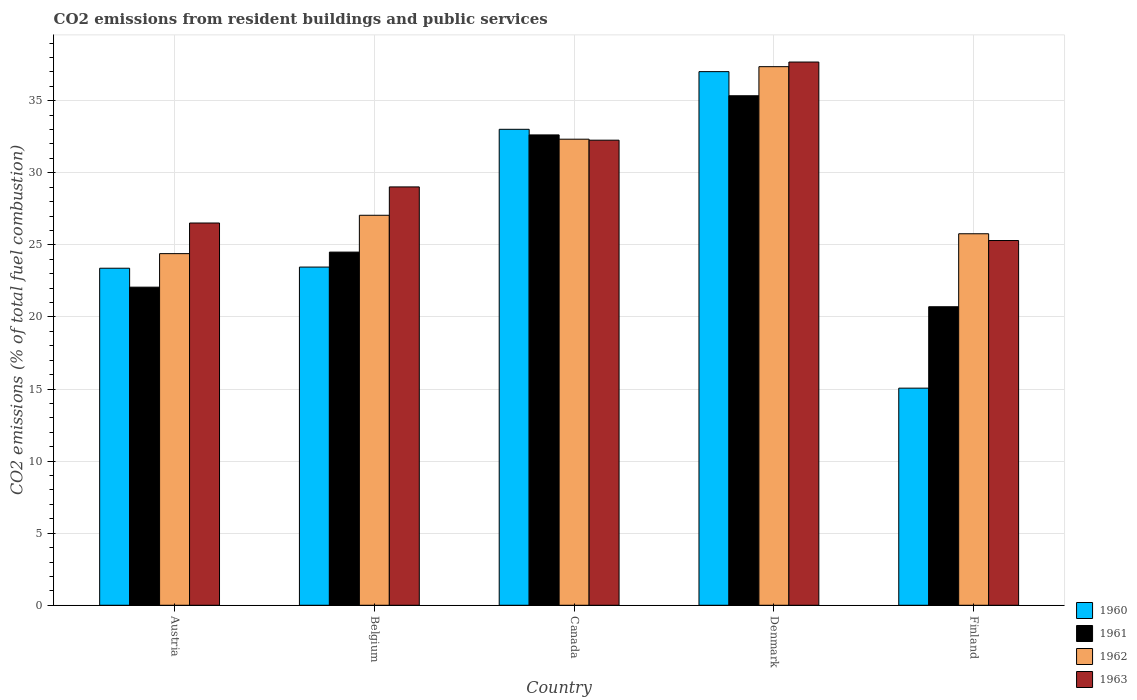How many different coloured bars are there?
Your response must be concise. 4. How many groups of bars are there?
Your answer should be very brief. 5. Are the number of bars on each tick of the X-axis equal?
Provide a short and direct response. Yes. In how many cases, is the number of bars for a given country not equal to the number of legend labels?
Your response must be concise. 0. What is the total CO2 emitted in 1960 in Austria?
Make the answer very short. 23.38. Across all countries, what is the maximum total CO2 emitted in 1960?
Keep it short and to the point. 37.02. Across all countries, what is the minimum total CO2 emitted in 1963?
Your response must be concise. 25.3. In which country was the total CO2 emitted in 1962 minimum?
Give a very brief answer. Austria. What is the total total CO2 emitted in 1962 in the graph?
Give a very brief answer. 146.9. What is the difference between the total CO2 emitted in 1963 in Austria and that in Denmark?
Provide a succinct answer. -11.17. What is the difference between the total CO2 emitted in 1963 in Belgium and the total CO2 emitted in 1962 in Canada?
Your response must be concise. -3.31. What is the average total CO2 emitted in 1962 per country?
Offer a terse response. 29.38. What is the difference between the total CO2 emitted of/in 1963 and total CO2 emitted of/in 1960 in Canada?
Make the answer very short. -0.75. What is the ratio of the total CO2 emitted in 1960 in Austria to that in Belgium?
Your answer should be very brief. 1. Is the total CO2 emitted in 1963 in Austria less than that in Denmark?
Offer a very short reply. Yes. What is the difference between the highest and the second highest total CO2 emitted in 1960?
Provide a short and direct response. -4. What is the difference between the highest and the lowest total CO2 emitted in 1961?
Ensure brevity in your answer.  14.64. In how many countries, is the total CO2 emitted in 1961 greater than the average total CO2 emitted in 1961 taken over all countries?
Make the answer very short. 2. Is the sum of the total CO2 emitted in 1961 in Belgium and Denmark greater than the maximum total CO2 emitted in 1960 across all countries?
Your answer should be compact. Yes. Is it the case that in every country, the sum of the total CO2 emitted in 1960 and total CO2 emitted in 1962 is greater than the sum of total CO2 emitted in 1963 and total CO2 emitted in 1961?
Keep it short and to the point. No. What does the 2nd bar from the right in Belgium represents?
Provide a succinct answer. 1962. How many bars are there?
Keep it short and to the point. 20. Are the values on the major ticks of Y-axis written in scientific E-notation?
Make the answer very short. No. Does the graph contain any zero values?
Provide a short and direct response. No. Does the graph contain grids?
Your answer should be compact. Yes. How many legend labels are there?
Keep it short and to the point. 4. What is the title of the graph?
Make the answer very short. CO2 emissions from resident buildings and public services. What is the label or title of the X-axis?
Your answer should be compact. Country. What is the label or title of the Y-axis?
Provide a short and direct response. CO2 emissions (% of total fuel combustion). What is the CO2 emissions (% of total fuel combustion) in 1960 in Austria?
Make the answer very short. 23.38. What is the CO2 emissions (% of total fuel combustion) in 1961 in Austria?
Give a very brief answer. 22.06. What is the CO2 emissions (% of total fuel combustion) of 1962 in Austria?
Ensure brevity in your answer.  24.39. What is the CO2 emissions (% of total fuel combustion) of 1963 in Austria?
Give a very brief answer. 26.52. What is the CO2 emissions (% of total fuel combustion) of 1960 in Belgium?
Ensure brevity in your answer.  23.46. What is the CO2 emissions (% of total fuel combustion) in 1961 in Belgium?
Keep it short and to the point. 24.5. What is the CO2 emissions (% of total fuel combustion) of 1962 in Belgium?
Your answer should be very brief. 27.05. What is the CO2 emissions (% of total fuel combustion) of 1963 in Belgium?
Provide a short and direct response. 29.02. What is the CO2 emissions (% of total fuel combustion) of 1960 in Canada?
Offer a terse response. 33.01. What is the CO2 emissions (% of total fuel combustion) of 1961 in Canada?
Offer a terse response. 32.63. What is the CO2 emissions (% of total fuel combustion) of 1962 in Canada?
Provide a succinct answer. 32.33. What is the CO2 emissions (% of total fuel combustion) of 1963 in Canada?
Make the answer very short. 32.26. What is the CO2 emissions (% of total fuel combustion) in 1960 in Denmark?
Provide a succinct answer. 37.02. What is the CO2 emissions (% of total fuel combustion) of 1961 in Denmark?
Provide a short and direct response. 35.34. What is the CO2 emissions (% of total fuel combustion) in 1962 in Denmark?
Provide a short and direct response. 37.36. What is the CO2 emissions (% of total fuel combustion) of 1963 in Denmark?
Provide a short and direct response. 37.68. What is the CO2 emissions (% of total fuel combustion) in 1960 in Finland?
Provide a short and direct response. 15.06. What is the CO2 emissions (% of total fuel combustion) in 1961 in Finland?
Provide a short and direct response. 20.71. What is the CO2 emissions (% of total fuel combustion) of 1962 in Finland?
Provide a short and direct response. 25.77. What is the CO2 emissions (% of total fuel combustion) of 1963 in Finland?
Your response must be concise. 25.3. Across all countries, what is the maximum CO2 emissions (% of total fuel combustion) in 1960?
Your answer should be very brief. 37.02. Across all countries, what is the maximum CO2 emissions (% of total fuel combustion) in 1961?
Your response must be concise. 35.34. Across all countries, what is the maximum CO2 emissions (% of total fuel combustion) of 1962?
Provide a succinct answer. 37.36. Across all countries, what is the maximum CO2 emissions (% of total fuel combustion) of 1963?
Your response must be concise. 37.68. Across all countries, what is the minimum CO2 emissions (% of total fuel combustion) of 1960?
Offer a terse response. 15.06. Across all countries, what is the minimum CO2 emissions (% of total fuel combustion) of 1961?
Make the answer very short. 20.71. Across all countries, what is the minimum CO2 emissions (% of total fuel combustion) of 1962?
Your response must be concise. 24.39. Across all countries, what is the minimum CO2 emissions (% of total fuel combustion) in 1963?
Your answer should be very brief. 25.3. What is the total CO2 emissions (% of total fuel combustion) in 1960 in the graph?
Offer a very short reply. 131.93. What is the total CO2 emissions (% of total fuel combustion) of 1961 in the graph?
Provide a short and direct response. 135.24. What is the total CO2 emissions (% of total fuel combustion) of 1962 in the graph?
Ensure brevity in your answer.  146.9. What is the total CO2 emissions (% of total fuel combustion) of 1963 in the graph?
Provide a short and direct response. 150.78. What is the difference between the CO2 emissions (% of total fuel combustion) in 1960 in Austria and that in Belgium?
Ensure brevity in your answer.  -0.08. What is the difference between the CO2 emissions (% of total fuel combustion) in 1961 in Austria and that in Belgium?
Provide a short and direct response. -2.43. What is the difference between the CO2 emissions (% of total fuel combustion) in 1962 in Austria and that in Belgium?
Make the answer very short. -2.66. What is the difference between the CO2 emissions (% of total fuel combustion) in 1963 in Austria and that in Belgium?
Keep it short and to the point. -2.5. What is the difference between the CO2 emissions (% of total fuel combustion) of 1960 in Austria and that in Canada?
Make the answer very short. -9.64. What is the difference between the CO2 emissions (% of total fuel combustion) of 1961 in Austria and that in Canada?
Offer a terse response. -10.56. What is the difference between the CO2 emissions (% of total fuel combustion) of 1962 in Austria and that in Canada?
Your answer should be very brief. -7.94. What is the difference between the CO2 emissions (% of total fuel combustion) of 1963 in Austria and that in Canada?
Provide a succinct answer. -5.74. What is the difference between the CO2 emissions (% of total fuel combustion) in 1960 in Austria and that in Denmark?
Give a very brief answer. -13.64. What is the difference between the CO2 emissions (% of total fuel combustion) of 1961 in Austria and that in Denmark?
Keep it short and to the point. -13.28. What is the difference between the CO2 emissions (% of total fuel combustion) of 1962 in Austria and that in Denmark?
Your answer should be compact. -12.97. What is the difference between the CO2 emissions (% of total fuel combustion) of 1963 in Austria and that in Denmark?
Give a very brief answer. -11.17. What is the difference between the CO2 emissions (% of total fuel combustion) in 1960 in Austria and that in Finland?
Provide a succinct answer. 8.32. What is the difference between the CO2 emissions (% of total fuel combustion) in 1961 in Austria and that in Finland?
Your answer should be very brief. 1.36. What is the difference between the CO2 emissions (% of total fuel combustion) of 1962 in Austria and that in Finland?
Offer a very short reply. -1.38. What is the difference between the CO2 emissions (% of total fuel combustion) of 1963 in Austria and that in Finland?
Provide a short and direct response. 1.22. What is the difference between the CO2 emissions (% of total fuel combustion) in 1960 in Belgium and that in Canada?
Give a very brief answer. -9.56. What is the difference between the CO2 emissions (% of total fuel combustion) in 1961 in Belgium and that in Canada?
Offer a terse response. -8.13. What is the difference between the CO2 emissions (% of total fuel combustion) of 1962 in Belgium and that in Canada?
Your answer should be compact. -5.28. What is the difference between the CO2 emissions (% of total fuel combustion) in 1963 in Belgium and that in Canada?
Make the answer very short. -3.24. What is the difference between the CO2 emissions (% of total fuel combustion) in 1960 in Belgium and that in Denmark?
Provide a succinct answer. -13.56. What is the difference between the CO2 emissions (% of total fuel combustion) in 1961 in Belgium and that in Denmark?
Ensure brevity in your answer.  -10.85. What is the difference between the CO2 emissions (% of total fuel combustion) in 1962 in Belgium and that in Denmark?
Make the answer very short. -10.31. What is the difference between the CO2 emissions (% of total fuel combustion) in 1963 in Belgium and that in Denmark?
Ensure brevity in your answer.  -8.66. What is the difference between the CO2 emissions (% of total fuel combustion) of 1960 in Belgium and that in Finland?
Your answer should be very brief. 8.4. What is the difference between the CO2 emissions (% of total fuel combustion) of 1961 in Belgium and that in Finland?
Ensure brevity in your answer.  3.79. What is the difference between the CO2 emissions (% of total fuel combustion) in 1962 in Belgium and that in Finland?
Your answer should be very brief. 1.28. What is the difference between the CO2 emissions (% of total fuel combustion) in 1963 in Belgium and that in Finland?
Ensure brevity in your answer.  3.72. What is the difference between the CO2 emissions (% of total fuel combustion) of 1960 in Canada and that in Denmark?
Make the answer very short. -4. What is the difference between the CO2 emissions (% of total fuel combustion) of 1961 in Canada and that in Denmark?
Ensure brevity in your answer.  -2.72. What is the difference between the CO2 emissions (% of total fuel combustion) of 1962 in Canada and that in Denmark?
Your answer should be very brief. -5.03. What is the difference between the CO2 emissions (% of total fuel combustion) of 1963 in Canada and that in Denmark?
Give a very brief answer. -5.42. What is the difference between the CO2 emissions (% of total fuel combustion) of 1960 in Canada and that in Finland?
Provide a succinct answer. 17.96. What is the difference between the CO2 emissions (% of total fuel combustion) of 1961 in Canada and that in Finland?
Provide a short and direct response. 11.92. What is the difference between the CO2 emissions (% of total fuel combustion) of 1962 in Canada and that in Finland?
Your response must be concise. 6.56. What is the difference between the CO2 emissions (% of total fuel combustion) in 1963 in Canada and that in Finland?
Keep it short and to the point. 6.96. What is the difference between the CO2 emissions (% of total fuel combustion) in 1960 in Denmark and that in Finland?
Make the answer very short. 21.96. What is the difference between the CO2 emissions (% of total fuel combustion) of 1961 in Denmark and that in Finland?
Make the answer very short. 14.64. What is the difference between the CO2 emissions (% of total fuel combustion) of 1962 in Denmark and that in Finland?
Give a very brief answer. 11.59. What is the difference between the CO2 emissions (% of total fuel combustion) of 1963 in Denmark and that in Finland?
Offer a terse response. 12.38. What is the difference between the CO2 emissions (% of total fuel combustion) in 1960 in Austria and the CO2 emissions (% of total fuel combustion) in 1961 in Belgium?
Offer a terse response. -1.12. What is the difference between the CO2 emissions (% of total fuel combustion) of 1960 in Austria and the CO2 emissions (% of total fuel combustion) of 1962 in Belgium?
Ensure brevity in your answer.  -3.67. What is the difference between the CO2 emissions (% of total fuel combustion) in 1960 in Austria and the CO2 emissions (% of total fuel combustion) in 1963 in Belgium?
Keep it short and to the point. -5.64. What is the difference between the CO2 emissions (% of total fuel combustion) of 1961 in Austria and the CO2 emissions (% of total fuel combustion) of 1962 in Belgium?
Keep it short and to the point. -4.99. What is the difference between the CO2 emissions (% of total fuel combustion) of 1961 in Austria and the CO2 emissions (% of total fuel combustion) of 1963 in Belgium?
Your response must be concise. -6.95. What is the difference between the CO2 emissions (% of total fuel combustion) of 1962 in Austria and the CO2 emissions (% of total fuel combustion) of 1963 in Belgium?
Provide a succinct answer. -4.63. What is the difference between the CO2 emissions (% of total fuel combustion) of 1960 in Austria and the CO2 emissions (% of total fuel combustion) of 1961 in Canada?
Ensure brevity in your answer.  -9.25. What is the difference between the CO2 emissions (% of total fuel combustion) of 1960 in Austria and the CO2 emissions (% of total fuel combustion) of 1962 in Canada?
Offer a very short reply. -8.95. What is the difference between the CO2 emissions (% of total fuel combustion) in 1960 in Austria and the CO2 emissions (% of total fuel combustion) in 1963 in Canada?
Ensure brevity in your answer.  -8.88. What is the difference between the CO2 emissions (% of total fuel combustion) of 1961 in Austria and the CO2 emissions (% of total fuel combustion) of 1962 in Canada?
Your response must be concise. -10.26. What is the difference between the CO2 emissions (% of total fuel combustion) of 1961 in Austria and the CO2 emissions (% of total fuel combustion) of 1963 in Canada?
Offer a terse response. -10.2. What is the difference between the CO2 emissions (% of total fuel combustion) in 1962 in Austria and the CO2 emissions (% of total fuel combustion) in 1963 in Canada?
Keep it short and to the point. -7.87. What is the difference between the CO2 emissions (% of total fuel combustion) of 1960 in Austria and the CO2 emissions (% of total fuel combustion) of 1961 in Denmark?
Your answer should be compact. -11.96. What is the difference between the CO2 emissions (% of total fuel combustion) of 1960 in Austria and the CO2 emissions (% of total fuel combustion) of 1962 in Denmark?
Keep it short and to the point. -13.98. What is the difference between the CO2 emissions (% of total fuel combustion) of 1960 in Austria and the CO2 emissions (% of total fuel combustion) of 1963 in Denmark?
Ensure brevity in your answer.  -14.3. What is the difference between the CO2 emissions (% of total fuel combustion) in 1961 in Austria and the CO2 emissions (% of total fuel combustion) in 1962 in Denmark?
Your response must be concise. -15.3. What is the difference between the CO2 emissions (% of total fuel combustion) in 1961 in Austria and the CO2 emissions (% of total fuel combustion) in 1963 in Denmark?
Your answer should be compact. -15.62. What is the difference between the CO2 emissions (% of total fuel combustion) in 1962 in Austria and the CO2 emissions (% of total fuel combustion) in 1963 in Denmark?
Keep it short and to the point. -13.29. What is the difference between the CO2 emissions (% of total fuel combustion) of 1960 in Austria and the CO2 emissions (% of total fuel combustion) of 1961 in Finland?
Offer a very short reply. 2.67. What is the difference between the CO2 emissions (% of total fuel combustion) of 1960 in Austria and the CO2 emissions (% of total fuel combustion) of 1962 in Finland?
Provide a succinct answer. -2.39. What is the difference between the CO2 emissions (% of total fuel combustion) of 1960 in Austria and the CO2 emissions (% of total fuel combustion) of 1963 in Finland?
Keep it short and to the point. -1.92. What is the difference between the CO2 emissions (% of total fuel combustion) in 1961 in Austria and the CO2 emissions (% of total fuel combustion) in 1962 in Finland?
Your response must be concise. -3.71. What is the difference between the CO2 emissions (% of total fuel combustion) in 1961 in Austria and the CO2 emissions (% of total fuel combustion) in 1963 in Finland?
Give a very brief answer. -3.24. What is the difference between the CO2 emissions (% of total fuel combustion) in 1962 in Austria and the CO2 emissions (% of total fuel combustion) in 1963 in Finland?
Give a very brief answer. -0.91. What is the difference between the CO2 emissions (% of total fuel combustion) in 1960 in Belgium and the CO2 emissions (% of total fuel combustion) in 1961 in Canada?
Give a very brief answer. -9.17. What is the difference between the CO2 emissions (% of total fuel combustion) of 1960 in Belgium and the CO2 emissions (% of total fuel combustion) of 1962 in Canada?
Offer a very short reply. -8.87. What is the difference between the CO2 emissions (% of total fuel combustion) of 1960 in Belgium and the CO2 emissions (% of total fuel combustion) of 1963 in Canada?
Your answer should be very brief. -8.8. What is the difference between the CO2 emissions (% of total fuel combustion) in 1961 in Belgium and the CO2 emissions (% of total fuel combustion) in 1962 in Canada?
Offer a very short reply. -7.83. What is the difference between the CO2 emissions (% of total fuel combustion) of 1961 in Belgium and the CO2 emissions (% of total fuel combustion) of 1963 in Canada?
Provide a succinct answer. -7.76. What is the difference between the CO2 emissions (% of total fuel combustion) in 1962 in Belgium and the CO2 emissions (% of total fuel combustion) in 1963 in Canada?
Your answer should be very brief. -5.21. What is the difference between the CO2 emissions (% of total fuel combustion) of 1960 in Belgium and the CO2 emissions (% of total fuel combustion) of 1961 in Denmark?
Your answer should be compact. -11.88. What is the difference between the CO2 emissions (% of total fuel combustion) in 1960 in Belgium and the CO2 emissions (% of total fuel combustion) in 1962 in Denmark?
Your answer should be very brief. -13.9. What is the difference between the CO2 emissions (% of total fuel combustion) in 1960 in Belgium and the CO2 emissions (% of total fuel combustion) in 1963 in Denmark?
Give a very brief answer. -14.22. What is the difference between the CO2 emissions (% of total fuel combustion) in 1961 in Belgium and the CO2 emissions (% of total fuel combustion) in 1962 in Denmark?
Keep it short and to the point. -12.86. What is the difference between the CO2 emissions (% of total fuel combustion) in 1961 in Belgium and the CO2 emissions (% of total fuel combustion) in 1963 in Denmark?
Provide a succinct answer. -13.18. What is the difference between the CO2 emissions (% of total fuel combustion) in 1962 in Belgium and the CO2 emissions (% of total fuel combustion) in 1963 in Denmark?
Make the answer very short. -10.63. What is the difference between the CO2 emissions (% of total fuel combustion) in 1960 in Belgium and the CO2 emissions (% of total fuel combustion) in 1961 in Finland?
Offer a very short reply. 2.75. What is the difference between the CO2 emissions (% of total fuel combustion) of 1960 in Belgium and the CO2 emissions (% of total fuel combustion) of 1962 in Finland?
Your answer should be very brief. -2.31. What is the difference between the CO2 emissions (% of total fuel combustion) in 1960 in Belgium and the CO2 emissions (% of total fuel combustion) in 1963 in Finland?
Give a very brief answer. -1.84. What is the difference between the CO2 emissions (% of total fuel combustion) in 1961 in Belgium and the CO2 emissions (% of total fuel combustion) in 1962 in Finland?
Provide a short and direct response. -1.27. What is the difference between the CO2 emissions (% of total fuel combustion) in 1961 in Belgium and the CO2 emissions (% of total fuel combustion) in 1963 in Finland?
Provide a short and direct response. -0.8. What is the difference between the CO2 emissions (% of total fuel combustion) of 1962 in Belgium and the CO2 emissions (% of total fuel combustion) of 1963 in Finland?
Ensure brevity in your answer.  1.75. What is the difference between the CO2 emissions (% of total fuel combustion) in 1960 in Canada and the CO2 emissions (% of total fuel combustion) in 1961 in Denmark?
Provide a succinct answer. -2.33. What is the difference between the CO2 emissions (% of total fuel combustion) in 1960 in Canada and the CO2 emissions (% of total fuel combustion) in 1962 in Denmark?
Your answer should be very brief. -4.35. What is the difference between the CO2 emissions (% of total fuel combustion) of 1960 in Canada and the CO2 emissions (% of total fuel combustion) of 1963 in Denmark?
Provide a succinct answer. -4.67. What is the difference between the CO2 emissions (% of total fuel combustion) in 1961 in Canada and the CO2 emissions (% of total fuel combustion) in 1962 in Denmark?
Your response must be concise. -4.73. What is the difference between the CO2 emissions (% of total fuel combustion) in 1961 in Canada and the CO2 emissions (% of total fuel combustion) in 1963 in Denmark?
Offer a very short reply. -5.06. What is the difference between the CO2 emissions (% of total fuel combustion) of 1962 in Canada and the CO2 emissions (% of total fuel combustion) of 1963 in Denmark?
Give a very brief answer. -5.35. What is the difference between the CO2 emissions (% of total fuel combustion) of 1960 in Canada and the CO2 emissions (% of total fuel combustion) of 1961 in Finland?
Your response must be concise. 12.31. What is the difference between the CO2 emissions (% of total fuel combustion) in 1960 in Canada and the CO2 emissions (% of total fuel combustion) in 1962 in Finland?
Provide a short and direct response. 7.25. What is the difference between the CO2 emissions (% of total fuel combustion) of 1960 in Canada and the CO2 emissions (% of total fuel combustion) of 1963 in Finland?
Offer a terse response. 7.71. What is the difference between the CO2 emissions (% of total fuel combustion) in 1961 in Canada and the CO2 emissions (% of total fuel combustion) in 1962 in Finland?
Offer a very short reply. 6.86. What is the difference between the CO2 emissions (% of total fuel combustion) in 1961 in Canada and the CO2 emissions (% of total fuel combustion) in 1963 in Finland?
Provide a short and direct response. 7.33. What is the difference between the CO2 emissions (% of total fuel combustion) in 1962 in Canada and the CO2 emissions (% of total fuel combustion) in 1963 in Finland?
Offer a terse response. 7.03. What is the difference between the CO2 emissions (% of total fuel combustion) of 1960 in Denmark and the CO2 emissions (% of total fuel combustion) of 1961 in Finland?
Provide a succinct answer. 16.31. What is the difference between the CO2 emissions (% of total fuel combustion) of 1960 in Denmark and the CO2 emissions (% of total fuel combustion) of 1962 in Finland?
Offer a terse response. 11.25. What is the difference between the CO2 emissions (% of total fuel combustion) of 1960 in Denmark and the CO2 emissions (% of total fuel combustion) of 1963 in Finland?
Offer a very short reply. 11.71. What is the difference between the CO2 emissions (% of total fuel combustion) of 1961 in Denmark and the CO2 emissions (% of total fuel combustion) of 1962 in Finland?
Make the answer very short. 9.57. What is the difference between the CO2 emissions (% of total fuel combustion) in 1961 in Denmark and the CO2 emissions (% of total fuel combustion) in 1963 in Finland?
Ensure brevity in your answer.  10.04. What is the difference between the CO2 emissions (% of total fuel combustion) of 1962 in Denmark and the CO2 emissions (% of total fuel combustion) of 1963 in Finland?
Keep it short and to the point. 12.06. What is the average CO2 emissions (% of total fuel combustion) of 1960 per country?
Offer a terse response. 26.39. What is the average CO2 emissions (% of total fuel combustion) in 1961 per country?
Make the answer very short. 27.05. What is the average CO2 emissions (% of total fuel combustion) in 1962 per country?
Give a very brief answer. 29.38. What is the average CO2 emissions (% of total fuel combustion) in 1963 per country?
Provide a short and direct response. 30.16. What is the difference between the CO2 emissions (% of total fuel combustion) in 1960 and CO2 emissions (% of total fuel combustion) in 1961 in Austria?
Make the answer very short. 1.31. What is the difference between the CO2 emissions (% of total fuel combustion) of 1960 and CO2 emissions (% of total fuel combustion) of 1962 in Austria?
Your response must be concise. -1.01. What is the difference between the CO2 emissions (% of total fuel combustion) of 1960 and CO2 emissions (% of total fuel combustion) of 1963 in Austria?
Provide a succinct answer. -3.14. What is the difference between the CO2 emissions (% of total fuel combustion) of 1961 and CO2 emissions (% of total fuel combustion) of 1962 in Austria?
Make the answer very short. -2.33. What is the difference between the CO2 emissions (% of total fuel combustion) of 1961 and CO2 emissions (% of total fuel combustion) of 1963 in Austria?
Your answer should be compact. -4.45. What is the difference between the CO2 emissions (% of total fuel combustion) in 1962 and CO2 emissions (% of total fuel combustion) in 1963 in Austria?
Provide a short and direct response. -2.12. What is the difference between the CO2 emissions (% of total fuel combustion) of 1960 and CO2 emissions (% of total fuel combustion) of 1961 in Belgium?
Give a very brief answer. -1.04. What is the difference between the CO2 emissions (% of total fuel combustion) in 1960 and CO2 emissions (% of total fuel combustion) in 1962 in Belgium?
Provide a short and direct response. -3.59. What is the difference between the CO2 emissions (% of total fuel combustion) of 1960 and CO2 emissions (% of total fuel combustion) of 1963 in Belgium?
Make the answer very short. -5.56. What is the difference between the CO2 emissions (% of total fuel combustion) in 1961 and CO2 emissions (% of total fuel combustion) in 1962 in Belgium?
Your answer should be compact. -2.55. What is the difference between the CO2 emissions (% of total fuel combustion) of 1961 and CO2 emissions (% of total fuel combustion) of 1963 in Belgium?
Give a very brief answer. -4.52. What is the difference between the CO2 emissions (% of total fuel combustion) of 1962 and CO2 emissions (% of total fuel combustion) of 1963 in Belgium?
Offer a very short reply. -1.97. What is the difference between the CO2 emissions (% of total fuel combustion) of 1960 and CO2 emissions (% of total fuel combustion) of 1961 in Canada?
Your answer should be very brief. 0.39. What is the difference between the CO2 emissions (% of total fuel combustion) of 1960 and CO2 emissions (% of total fuel combustion) of 1962 in Canada?
Make the answer very short. 0.69. What is the difference between the CO2 emissions (% of total fuel combustion) of 1960 and CO2 emissions (% of total fuel combustion) of 1963 in Canada?
Ensure brevity in your answer.  0.75. What is the difference between the CO2 emissions (% of total fuel combustion) of 1961 and CO2 emissions (% of total fuel combustion) of 1962 in Canada?
Provide a succinct answer. 0.3. What is the difference between the CO2 emissions (% of total fuel combustion) of 1961 and CO2 emissions (% of total fuel combustion) of 1963 in Canada?
Make the answer very short. 0.37. What is the difference between the CO2 emissions (% of total fuel combustion) in 1962 and CO2 emissions (% of total fuel combustion) in 1963 in Canada?
Offer a very short reply. 0.07. What is the difference between the CO2 emissions (% of total fuel combustion) of 1960 and CO2 emissions (% of total fuel combustion) of 1961 in Denmark?
Give a very brief answer. 1.67. What is the difference between the CO2 emissions (% of total fuel combustion) in 1960 and CO2 emissions (% of total fuel combustion) in 1962 in Denmark?
Keep it short and to the point. -0.34. What is the difference between the CO2 emissions (% of total fuel combustion) of 1960 and CO2 emissions (% of total fuel combustion) of 1963 in Denmark?
Provide a succinct answer. -0.67. What is the difference between the CO2 emissions (% of total fuel combustion) of 1961 and CO2 emissions (% of total fuel combustion) of 1962 in Denmark?
Give a very brief answer. -2.02. What is the difference between the CO2 emissions (% of total fuel combustion) in 1961 and CO2 emissions (% of total fuel combustion) in 1963 in Denmark?
Provide a succinct answer. -2.34. What is the difference between the CO2 emissions (% of total fuel combustion) of 1962 and CO2 emissions (% of total fuel combustion) of 1963 in Denmark?
Your response must be concise. -0.32. What is the difference between the CO2 emissions (% of total fuel combustion) of 1960 and CO2 emissions (% of total fuel combustion) of 1961 in Finland?
Make the answer very short. -5.65. What is the difference between the CO2 emissions (% of total fuel combustion) in 1960 and CO2 emissions (% of total fuel combustion) in 1962 in Finland?
Your answer should be very brief. -10.71. What is the difference between the CO2 emissions (% of total fuel combustion) of 1960 and CO2 emissions (% of total fuel combustion) of 1963 in Finland?
Give a very brief answer. -10.24. What is the difference between the CO2 emissions (% of total fuel combustion) of 1961 and CO2 emissions (% of total fuel combustion) of 1962 in Finland?
Offer a terse response. -5.06. What is the difference between the CO2 emissions (% of total fuel combustion) of 1961 and CO2 emissions (% of total fuel combustion) of 1963 in Finland?
Offer a very short reply. -4.59. What is the difference between the CO2 emissions (% of total fuel combustion) in 1962 and CO2 emissions (% of total fuel combustion) in 1963 in Finland?
Give a very brief answer. 0.47. What is the ratio of the CO2 emissions (% of total fuel combustion) of 1960 in Austria to that in Belgium?
Your answer should be very brief. 1. What is the ratio of the CO2 emissions (% of total fuel combustion) in 1961 in Austria to that in Belgium?
Provide a short and direct response. 0.9. What is the ratio of the CO2 emissions (% of total fuel combustion) in 1962 in Austria to that in Belgium?
Provide a succinct answer. 0.9. What is the ratio of the CO2 emissions (% of total fuel combustion) in 1963 in Austria to that in Belgium?
Keep it short and to the point. 0.91. What is the ratio of the CO2 emissions (% of total fuel combustion) in 1960 in Austria to that in Canada?
Keep it short and to the point. 0.71. What is the ratio of the CO2 emissions (% of total fuel combustion) of 1961 in Austria to that in Canada?
Offer a terse response. 0.68. What is the ratio of the CO2 emissions (% of total fuel combustion) of 1962 in Austria to that in Canada?
Provide a short and direct response. 0.75. What is the ratio of the CO2 emissions (% of total fuel combustion) in 1963 in Austria to that in Canada?
Your answer should be compact. 0.82. What is the ratio of the CO2 emissions (% of total fuel combustion) in 1960 in Austria to that in Denmark?
Provide a short and direct response. 0.63. What is the ratio of the CO2 emissions (% of total fuel combustion) of 1961 in Austria to that in Denmark?
Provide a succinct answer. 0.62. What is the ratio of the CO2 emissions (% of total fuel combustion) of 1962 in Austria to that in Denmark?
Offer a very short reply. 0.65. What is the ratio of the CO2 emissions (% of total fuel combustion) in 1963 in Austria to that in Denmark?
Your response must be concise. 0.7. What is the ratio of the CO2 emissions (% of total fuel combustion) of 1960 in Austria to that in Finland?
Your answer should be compact. 1.55. What is the ratio of the CO2 emissions (% of total fuel combustion) in 1961 in Austria to that in Finland?
Keep it short and to the point. 1.07. What is the ratio of the CO2 emissions (% of total fuel combustion) of 1962 in Austria to that in Finland?
Keep it short and to the point. 0.95. What is the ratio of the CO2 emissions (% of total fuel combustion) of 1963 in Austria to that in Finland?
Provide a succinct answer. 1.05. What is the ratio of the CO2 emissions (% of total fuel combustion) in 1960 in Belgium to that in Canada?
Keep it short and to the point. 0.71. What is the ratio of the CO2 emissions (% of total fuel combustion) in 1961 in Belgium to that in Canada?
Offer a very short reply. 0.75. What is the ratio of the CO2 emissions (% of total fuel combustion) in 1962 in Belgium to that in Canada?
Provide a succinct answer. 0.84. What is the ratio of the CO2 emissions (% of total fuel combustion) of 1963 in Belgium to that in Canada?
Keep it short and to the point. 0.9. What is the ratio of the CO2 emissions (% of total fuel combustion) in 1960 in Belgium to that in Denmark?
Give a very brief answer. 0.63. What is the ratio of the CO2 emissions (% of total fuel combustion) of 1961 in Belgium to that in Denmark?
Give a very brief answer. 0.69. What is the ratio of the CO2 emissions (% of total fuel combustion) of 1962 in Belgium to that in Denmark?
Your response must be concise. 0.72. What is the ratio of the CO2 emissions (% of total fuel combustion) of 1963 in Belgium to that in Denmark?
Keep it short and to the point. 0.77. What is the ratio of the CO2 emissions (% of total fuel combustion) in 1960 in Belgium to that in Finland?
Ensure brevity in your answer.  1.56. What is the ratio of the CO2 emissions (% of total fuel combustion) of 1961 in Belgium to that in Finland?
Offer a terse response. 1.18. What is the ratio of the CO2 emissions (% of total fuel combustion) in 1962 in Belgium to that in Finland?
Make the answer very short. 1.05. What is the ratio of the CO2 emissions (% of total fuel combustion) of 1963 in Belgium to that in Finland?
Provide a short and direct response. 1.15. What is the ratio of the CO2 emissions (% of total fuel combustion) of 1960 in Canada to that in Denmark?
Offer a very short reply. 0.89. What is the ratio of the CO2 emissions (% of total fuel combustion) in 1962 in Canada to that in Denmark?
Your answer should be very brief. 0.87. What is the ratio of the CO2 emissions (% of total fuel combustion) of 1963 in Canada to that in Denmark?
Provide a succinct answer. 0.86. What is the ratio of the CO2 emissions (% of total fuel combustion) of 1960 in Canada to that in Finland?
Your answer should be compact. 2.19. What is the ratio of the CO2 emissions (% of total fuel combustion) in 1961 in Canada to that in Finland?
Your answer should be very brief. 1.58. What is the ratio of the CO2 emissions (% of total fuel combustion) of 1962 in Canada to that in Finland?
Keep it short and to the point. 1.25. What is the ratio of the CO2 emissions (% of total fuel combustion) of 1963 in Canada to that in Finland?
Your response must be concise. 1.28. What is the ratio of the CO2 emissions (% of total fuel combustion) of 1960 in Denmark to that in Finland?
Make the answer very short. 2.46. What is the ratio of the CO2 emissions (% of total fuel combustion) in 1961 in Denmark to that in Finland?
Give a very brief answer. 1.71. What is the ratio of the CO2 emissions (% of total fuel combustion) in 1962 in Denmark to that in Finland?
Give a very brief answer. 1.45. What is the ratio of the CO2 emissions (% of total fuel combustion) in 1963 in Denmark to that in Finland?
Make the answer very short. 1.49. What is the difference between the highest and the second highest CO2 emissions (% of total fuel combustion) of 1960?
Offer a very short reply. 4. What is the difference between the highest and the second highest CO2 emissions (% of total fuel combustion) of 1961?
Your answer should be very brief. 2.72. What is the difference between the highest and the second highest CO2 emissions (% of total fuel combustion) of 1962?
Provide a succinct answer. 5.03. What is the difference between the highest and the second highest CO2 emissions (% of total fuel combustion) in 1963?
Make the answer very short. 5.42. What is the difference between the highest and the lowest CO2 emissions (% of total fuel combustion) of 1960?
Make the answer very short. 21.96. What is the difference between the highest and the lowest CO2 emissions (% of total fuel combustion) of 1961?
Offer a very short reply. 14.64. What is the difference between the highest and the lowest CO2 emissions (% of total fuel combustion) in 1962?
Offer a very short reply. 12.97. What is the difference between the highest and the lowest CO2 emissions (% of total fuel combustion) of 1963?
Your answer should be compact. 12.38. 